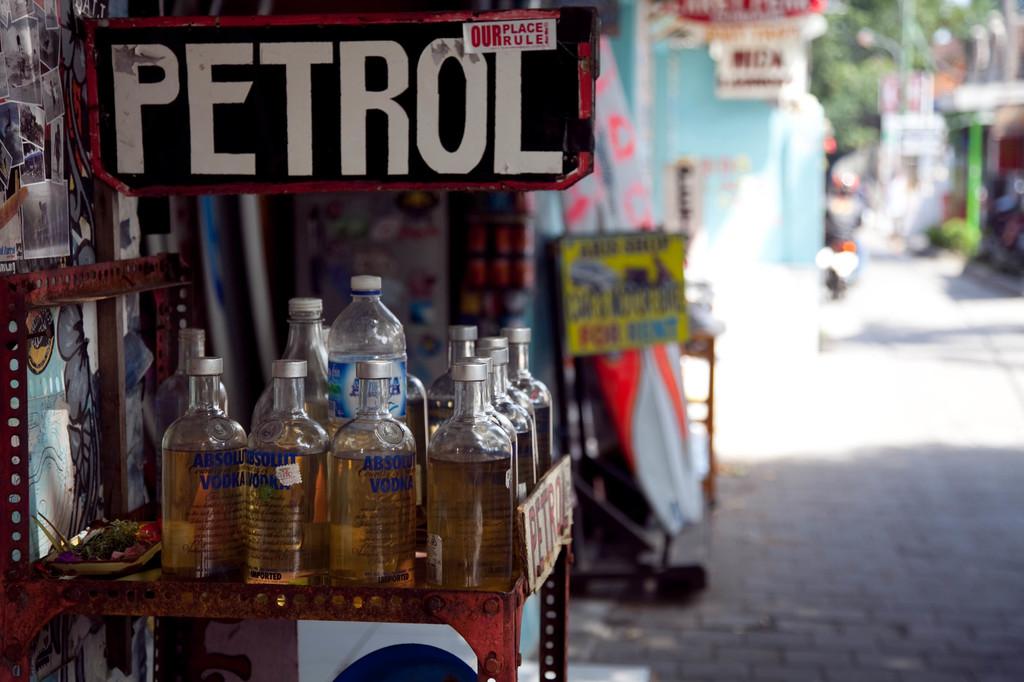What does the sticker on the petrol sign say?
Your answer should be compact. Our place rule. 